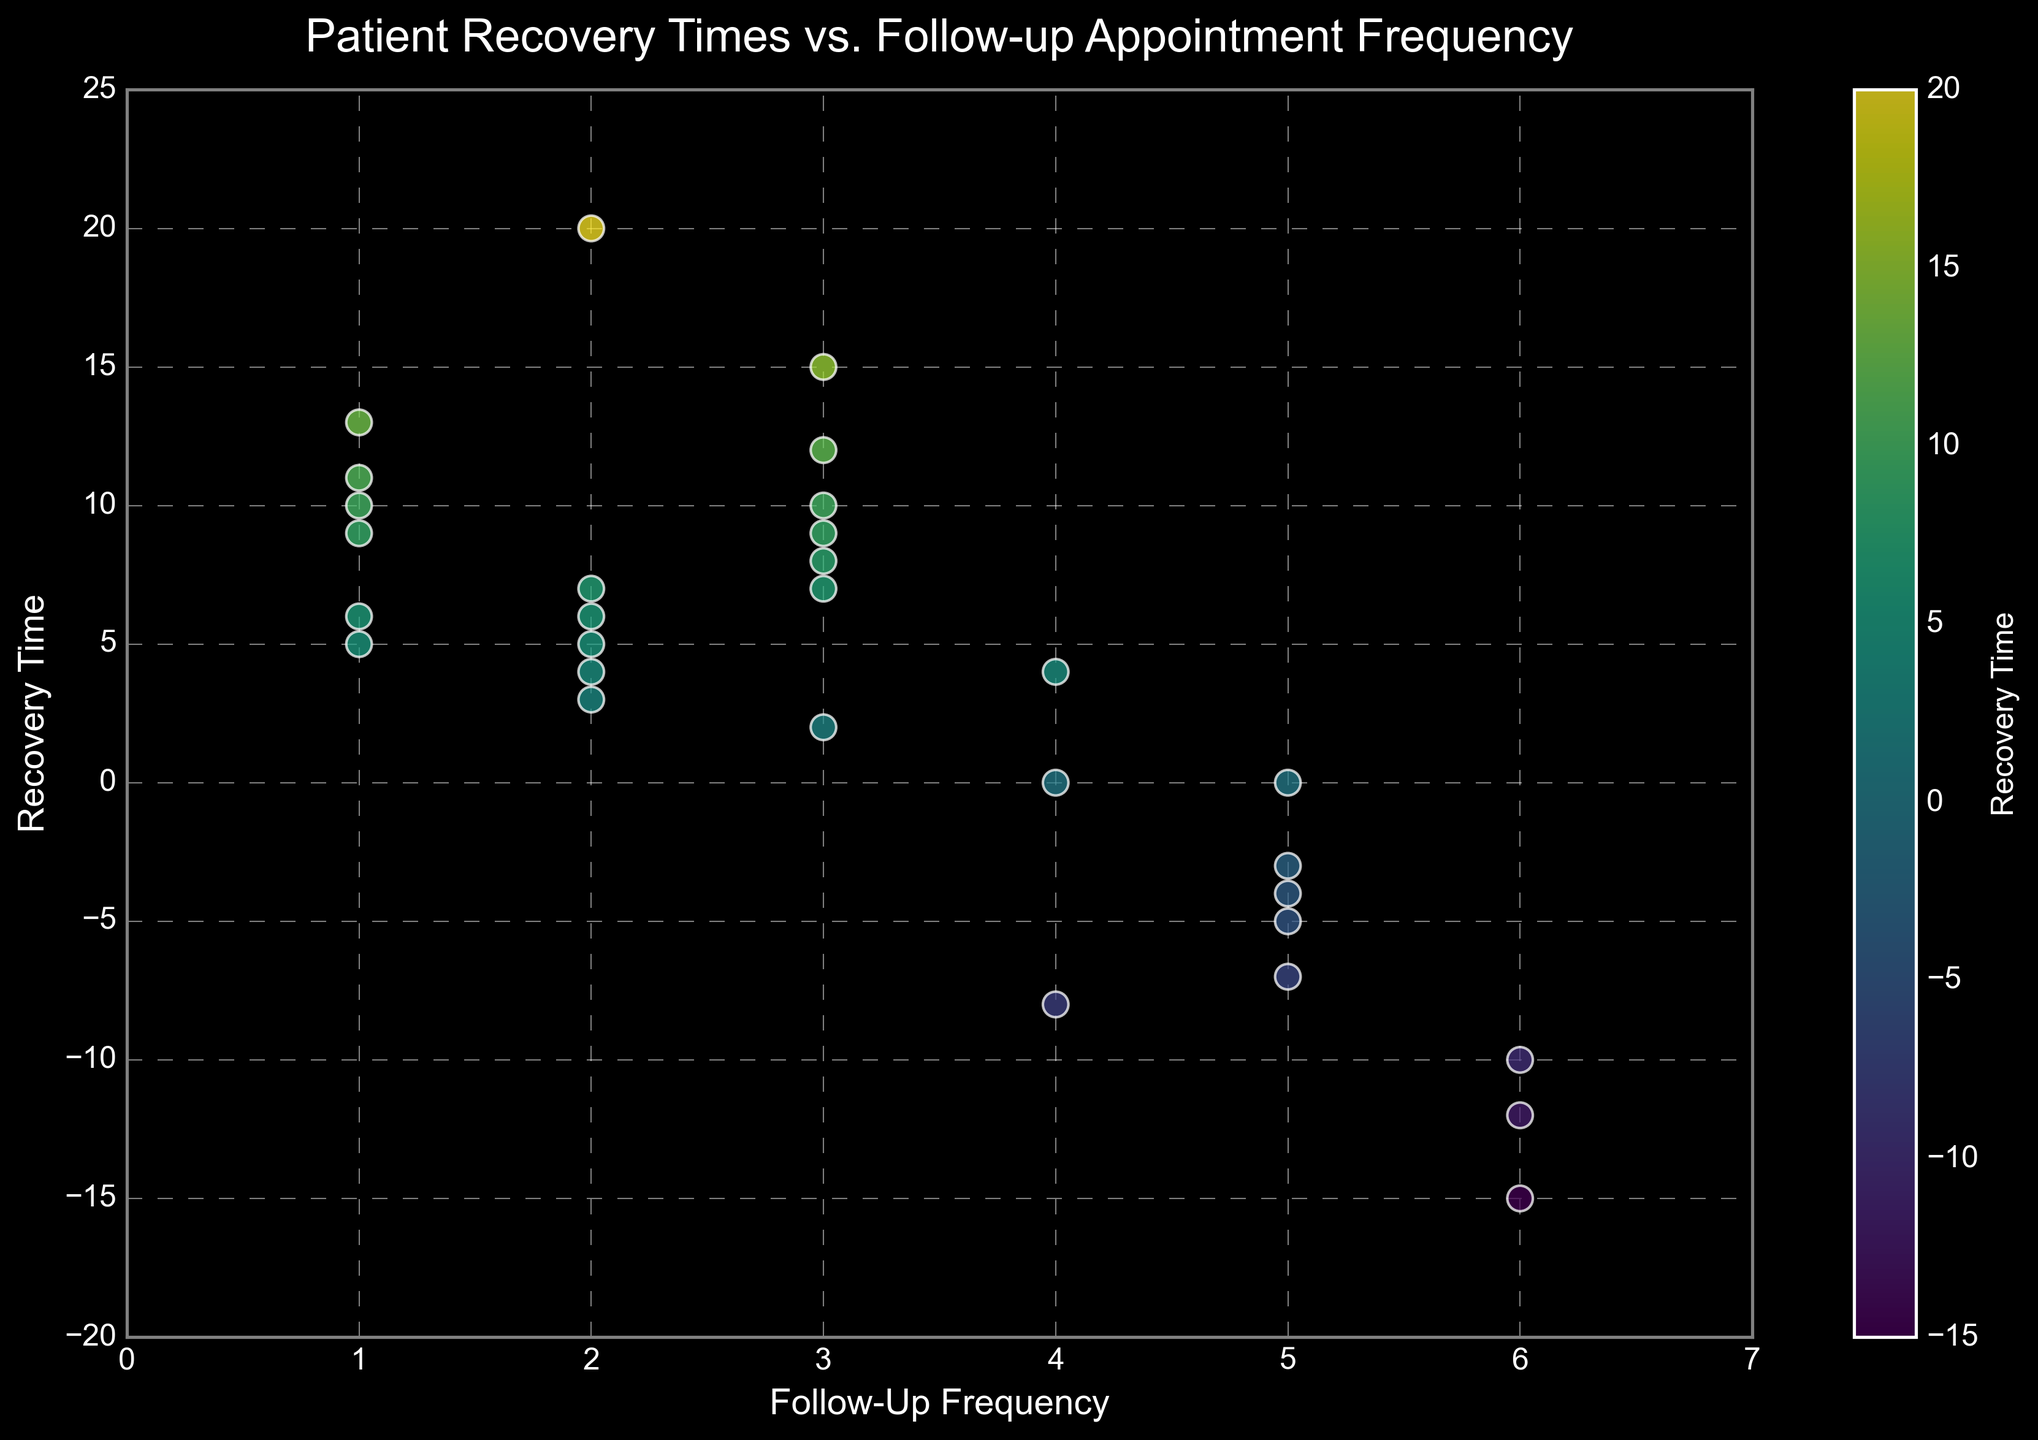Which Follow-Up Frequency shows the widest range of Recovery Times? By observing the scatter plot, identify the Follow-Up Frequency (x-axis) with the maximum spread of points along the y-axis (Recovery Time). Compare the extent of the vertical spread across different Follow-Up Frequencies.
Answer: 5 Which Follow-Up Frequency has the most positive Recovery Times? Count how many points have a positive Recovery Time for each Follow-Up Frequency on the scatter plot. Follow-Up Frequency 3 has the highest positive Recovery Times.
Answer: 3 Is there any Follow-Up Frequency with only negative Recovery Times? Look for any Follow-Up Frequency value along the x-axis that has all its corresponding Recovery Time points (y-axis) below zero. There is no such frequency where all recovery times are negative.
Answer: No What is the average Recovery Time for Follow-Up Frequency 3? Extract the Recovery Time values for Follow-Up Frequency 3, sum them up, and divide by the number of points. The values are (15 + 7 + 12 + 6 + 8 + 10 + 9 + 2); the sum is 69, and there are 8 points. 69/8 = 8.625
Answer: 8.625 Which Follow-Up Frequency shows the highest concentration of Recovery Times near zero? Identify the Follow-Up Frequency with several points clustered closest to zero on the y-axis. Follow-Up Frequency 3 has many points around zero but not the highest concentration. Hence, look towards frequencies with closely packed points near the zero y-line.
Answer: 4 What color represents the highest Recovery Time? Check the color scale (color bar) label on the right and find which color corresponds to the highest value on the recovery color spectrum.
Answer: Yellow Compare the Recovery Times for Follow-Up Frequencies 1 and 6: Which has a wider range? Identify and compare the vertical spread of Recovery Times between Follow-Up Frequency 1 and 6. Follow-Up Frequency 6 has points spread from -15 to -12, while Follow-Up Frequency 1 ranges from 9 to 13. The range for 6 is wider.
Answer: 6 Is there an evident trend between Follow-Up Frequency and Recovery Time? Look for a pattern where points form an increasing or decreasing line. The plot shows no clear increasing or decreasing trend, indicating no particular pattern between Follow-Up Frequency and Recovery Time.
Answer: No What is the median Recovery Time for Follow-Up Frequency 2? List the Recovery Times for Follow-Up Frequency 2 (5, 20, 3, 6, 4, 7), sort them: (3, 4, 5, 6, 7, 20), and find the middle value(s). The median lies between 5 and 6, averaging to 5.5.
Answer: 5.5 Which Follow-Up Frequency has the most scattered Recovery Times? Identify the Follow-Up Frequency where points are strikingly spread out vertically along the y-axis. Follow-Up Frequency 5 seems most scattered with values including -5, -4, -7, 0.
Answer: 5 